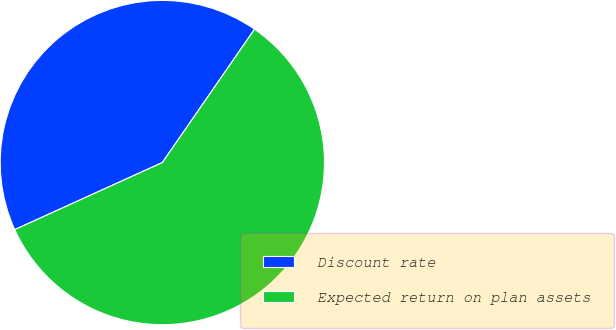Convert chart to OTSL. <chart><loc_0><loc_0><loc_500><loc_500><pie_chart><fcel>Discount rate<fcel>Expected return on plan assets<nl><fcel>41.42%<fcel>58.58%<nl></chart> 